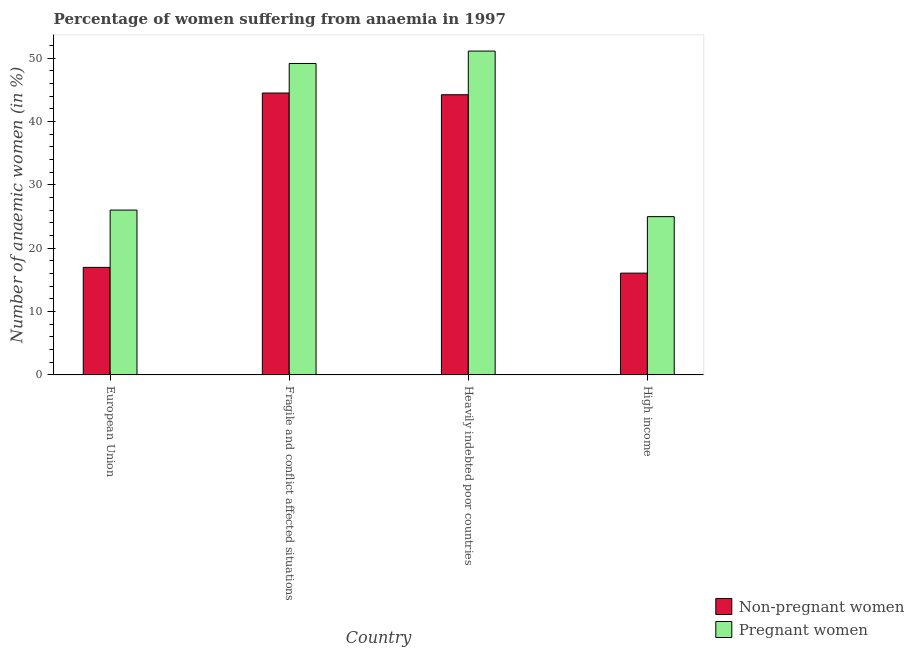How many groups of bars are there?
Offer a very short reply. 4. Are the number of bars per tick equal to the number of legend labels?
Your answer should be very brief. Yes. Are the number of bars on each tick of the X-axis equal?
Provide a short and direct response. Yes. How many bars are there on the 2nd tick from the left?
Your answer should be very brief. 2. What is the label of the 1st group of bars from the left?
Offer a very short reply. European Union. In how many cases, is the number of bars for a given country not equal to the number of legend labels?
Provide a short and direct response. 0. What is the percentage of pregnant anaemic women in High income?
Offer a terse response. 24.97. Across all countries, what is the maximum percentage of pregnant anaemic women?
Your response must be concise. 51.1. Across all countries, what is the minimum percentage of pregnant anaemic women?
Offer a very short reply. 24.97. In which country was the percentage of non-pregnant anaemic women maximum?
Offer a very short reply. Fragile and conflict affected situations. What is the total percentage of pregnant anaemic women in the graph?
Offer a very short reply. 151.23. What is the difference between the percentage of pregnant anaemic women in Heavily indebted poor countries and that in High income?
Make the answer very short. 26.13. What is the difference between the percentage of pregnant anaemic women in European Union and the percentage of non-pregnant anaemic women in High income?
Provide a succinct answer. 9.95. What is the average percentage of non-pregnant anaemic women per country?
Give a very brief answer. 30.43. What is the difference between the percentage of non-pregnant anaemic women and percentage of pregnant anaemic women in Fragile and conflict affected situations?
Make the answer very short. -4.66. What is the ratio of the percentage of pregnant anaemic women in Fragile and conflict affected situations to that in Heavily indebted poor countries?
Your answer should be compact. 0.96. Is the percentage of pregnant anaemic women in Fragile and conflict affected situations less than that in High income?
Your answer should be compact. No. What is the difference between the highest and the second highest percentage of non-pregnant anaemic women?
Keep it short and to the point. 0.27. What is the difference between the highest and the lowest percentage of non-pregnant anaemic women?
Offer a very short reply. 28.42. In how many countries, is the percentage of non-pregnant anaemic women greater than the average percentage of non-pregnant anaemic women taken over all countries?
Provide a short and direct response. 2. Is the sum of the percentage of pregnant anaemic women in European Union and Heavily indebted poor countries greater than the maximum percentage of non-pregnant anaemic women across all countries?
Ensure brevity in your answer.  Yes. What does the 2nd bar from the left in Heavily indebted poor countries represents?
Offer a very short reply. Pregnant women. What does the 2nd bar from the right in High income represents?
Make the answer very short. Non-pregnant women. Does the graph contain grids?
Your answer should be compact. No. Where does the legend appear in the graph?
Keep it short and to the point. Bottom right. How many legend labels are there?
Ensure brevity in your answer.  2. How are the legend labels stacked?
Your answer should be compact. Vertical. What is the title of the graph?
Offer a terse response. Percentage of women suffering from anaemia in 1997. What is the label or title of the X-axis?
Your answer should be very brief. Country. What is the label or title of the Y-axis?
Offer a very short reply. Number of anaemic women (in %). What is the Number of anaemic women (in %) in Non-pregnant women in European Union?
Give a very brief answer. 16.97. What is the Number of anaemic women (in %) of Pregnant women in European Union?
Offer a terse response. 26.01. What is the Number of anaemic women (in %) in Non-pregnant women in Fragile and conflict affected situations?
Your answer should be compact. 44.48. What is the Number of anaemic women (in %) in Pregnant women in Fragile and conflict affected situations?
Your answer should be very brief. 49.14. What is the Number of anaemic women (in %) in Non-pregnant women in Heavily indebted poor countries?
Your answer should be compact. 44.21. What is the Number of anaemic women (in %) in Pregnant women in Heavily indebted poor countries?
Give a very brief answer. 51.1. What is the Number of anaemic women (in %) of Non-pregnant women in High income?
Provide a short and direct response. 16.06. What is the Number of anaemic women (in %) in Pregnant women in High income?
Provide a succinct answer. 24.97. Across all countries, what is the maximum Number of anaemic women (in %) of Non-pregnant women?
Your response must be concise. 44.48. Across all countries, what is the maximum Number of anaemic women (in %) of Pregnant women?
Ensure brevity in your answer.  51.1. Across all countries, what is the minimum Number of anaemic women (in %) of Non-pregnant women?
Offer a terse response. 16.06. Across all countries, what is the minimum Number of anaemic women (in %) of Pregnant women?
Your answer should be compact. 24.97. What is the total Number of anaemic women (in %) of Non-pregnant women in the graph?
Make the answer very short. 121.71. What is the total Number of anaemic women (in %) of Pregnant women in the graph?
Your answer should be very brief. 151.23. What is the difference between the Number of anaemic women (in %) in Non-pregnant women in European Union and that in Fragile and conflict affected situations?
Your answer should be very brief. -27.51. What is the difference between the Number of anaemic women (in %) of Pregnant women in European Union and that in Fragile and conflict affected situations?
Keep it short and to the point. -23.13. What is the difference between the Number of anaemic women (in %) of Non-pregnant women in European Union and that in Heavily indebted poor countries?
Provide a succinct answer. -27.24. What is the difference between the Number of anaemic women (in %) in Pregnant women in European Union and that in Heavily indebted poor countries?
Make the answer very short. -25.09. What is the difference between the Number of anaemic women (in %) of Non-pregnant women in European Union and that in High income?
Your answer should be very brief. 0.91. What is the difference between the Number of anaemic women (in %) in Pregnant women in European Union and that in High income?
Make the answer very short. 1.04. What is the difference between the Number of anaemic women (in %) of Non-pregnant women in Fragile and conflict affected situations and that in Heavily indebted poor countries?
Provide a short and direct response. 0.27. What is the difference between the Number of anaemic women (in %) in Pregnant women in Fragile and conflict affected situations and that in Heavily indebted poor countries?
Provide a short and direct response. -1.96. What is the difference between the Number of anaemic women (in %) of Non-pregnant women in Fragile and conflict affected situations and that in High income?
Your response must be concise. 28.42. What is the difference between the Number of anaemic women (in %) in Pregnant women in Fragile and conflict affected situations and that in High income?
Your answer should be very brief. 24.17. What is the difference between the Number of anaemic women (in %) of Non-pregnant women in Heavily indebted poor countries and that in High income?
Your answer should be compact. 28.15. What is the difference between the Number of anaemic women (in %) in Pregnant women in Heavily indebted poor countries and that in High income?
Your answer should be very brief. 26.13. What is the difference between the Number of anaemic women (in %) of Non-pregnant women in European Union and the Number of anaemic women (in %) of Pregnant women in Fragile and conflict affected situations?
Your response must be concise. -32.18. What is the difference between the Number of anaemic women (in %) in Non-pregnant women in European Union and the Number of anaemic women (in %) in Pregnant women in Heavily indebted poor countries?
Offer a terse response. -34.13. What is the difference between the Number of anaemic women (in %) of Non-pregnant women in European Union and the Number of anaemic women (in %) of Pregnant women in High income?
Your answer should be compact. -8.01. What is the difference between the Number of anaemic women (in %) of Non-pregnant women in Fragile and conflict affected situations and the Number of anaemic women (in %) of Pregnant women in Heavily indebted poor countries?
Your response must be concise. -6.62. What is the difference between the Number of anaemic women (in %) in Non-pregnant women in Fragile and conflict affected situations and the Number of anaemic women (in %) in Pregnant women in High income?
Your response must be concise. 19.5. What is the difference between the Number of anaemic women (in %) of Non-pregnant women in Heavily indebted poor countries and the Number of anaemic women (in %) of Pregnant women in High income?
Your answer should be compact. 19.23. What is the average Number of anaemic women (in %) in Non-pregnant women per country?
Provide a short and direct response. 30.43. What is the average Number of anaemic women (in %) in Pregnant women per country?
Provide a short and direct response. 37.81. What is the difference between the Number of anaemic women (in %) in Non-pregnant women and Number of anaemic women (in %) in Pregnant women in European Union?
Ensure brevity in your answer.  -9.04. What is the difference between the Number of anaemic women (in %) in Non-pregnant women and Number of anaemic women (in %) in Pregnant women in Fragile and conflict affected situations?
Your answer should be very brief. -4.66. What is the difference between the Number of anaemic women (in %) in Non-pregnant women and Number of anaemic women (in %) in Pregnant women in Heavily indebted poor countries?
Ensure brevity in your answer.  -6.89. What is the difference between the Number of anaemic women (in %) of Non-pregnant women and Number of anaemic women (in %) of Pregnant women in High income?
Provide a succinct answer. -8.91. What is the ratio of the Number of anaemic women (in %) in Non-pregnant women in European Union to that in Fragile and conflict affected situations?
Your response must be concise. 0.38. What is the ratio of the Number of anaemic women (in %) in Pregnant women in European Union to that in Fragile and conflict affected situations?
Make the answer very short. 0.53. What is the ratio of the Number of anaemic women (in %) of Non-pregnant women in European Union to that in Heavily indebted poor countries?
Keep it short and to the point. 0.38. What is the ratio of the Number of anaemic women (in %) of Pregnant women in European Union to that in Heavily indebted poor countries?
Make the answer very short. 0.51. What is the ratio of the Number of anaemic women (in %) in Non-pregnant women in European Union to that in High income?
Offer a terse response. 1.06. What is the ratio of the Number of anaemic women (in %) of Pregnant women in European Union to that in High income?
Your response must be concise. 1.04. What is the ratio of the Number of anaemic women (in %) of Pregnant women in Fragile and conflict affected situations to that in Heavily indebted poor countries?
Make the answer very short. 0.96. What is the ratio of the Number of anaemic women (in %) in Non-pregnant women in Fragile and conflict affected situations to that in High income?
Offer a terse response. 2.77. What is the ratio of the Number of anaemic women (in %) in Pregnant women in Fragile and conflict affected situations to that in High income?
Your answer should be very brief. 1.97. What is the ratio of the Number of anaemic women (in %) of Non-pregnant women in Heavily indebted poor countries to that in High income?
Offer a very short reply. 2.75. What is the ratio of the Number of anaemic women (in %) in Pregnant women in Heavily indebted poor countries to that in High income?
Your answer should be very brief. 2.05. What is the difference between the highest and the second highest Number of anaemic women (in %) in Non-pregnant women?
Offer a terse response. 0.27. What is the difference between the highest and the second highest Number of anaemic women (in %) of Pregnant women?
Provide a short and direct response. 1.96. What is the difference between the highest and the lowest Number of anaemic women (in %) in Non-pregnant women?
Your answer should be very brief. 28.42. What is the difference between the highest and the lowest Number of anaemic women (in %) of Pregnant women?
Offer a terse response. 26.13. 